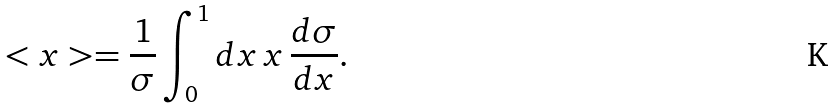Convert formula to latex. <formula><loc_0><loc_0><loc_500><loc_500>< x > = \frac { 1 } { \sigma } \int ^ { 1 } _ { 0 } d x \, x \, \frac { d \sigma } { d x } .</formula> 